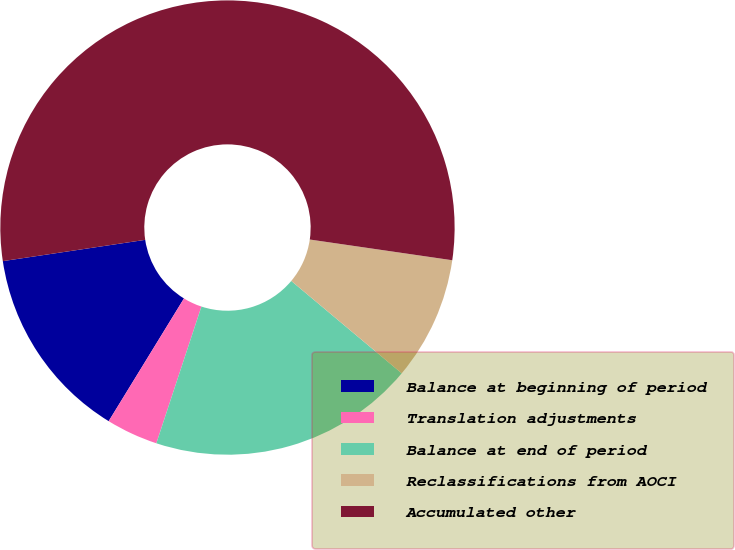Convert chart. <chart><loc_0><loc_0><loc_500><loc_500><pie_chart><fcel>Balance at beginning of period<fcel>Translation adjustments<fcel>Balance at end of period<fcel>Reclassifications from AOCI<fcel>Accumulated other<nl><fcel>13.88%<fcel>3.69%<fcel>18.98%<fcel>8.79%<fcel>54.66%<nl></chart> 